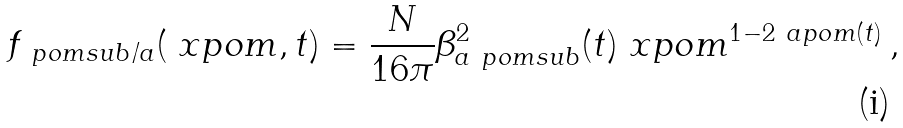<formula> <loc_0><loc_0><loc_500><loc_500>f _ { \ p o m s u b / a } ( \ x p o m , t ) = \frac { N } { 1 6 \pi } \beta _ { a \ p o m s u b } ^ { 2 } ( t ) \ x p o m ^ { 1 - 2 \ a p o m ( t ) } \, ,</formula> 